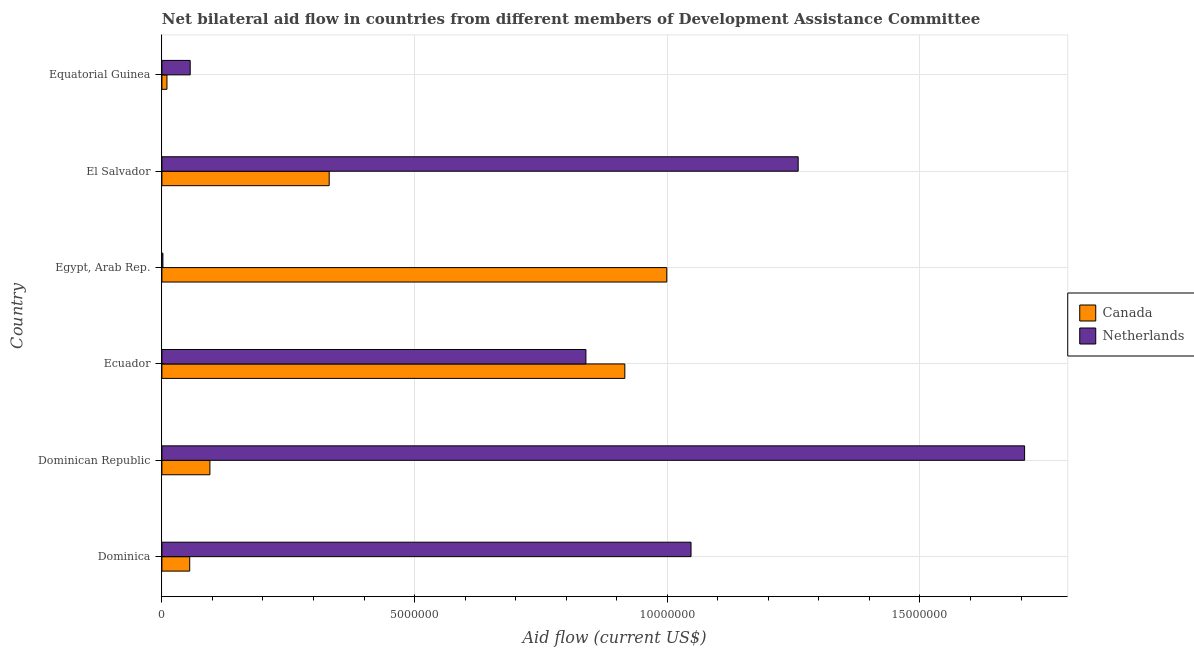How many different coloured bars are there?
Offer a very short reply. 2. Are the number of bars per tick equal to the number of legend labels?
Make the answer very short. Yes. Are the number of bars on each tick of the Y-axis equal?
Make the answer very short. Yes. How many bars are there on the 4th tick from the top?
Make the answer very short. 2. What is the label of the 3rd group of bars from the top?
Your answer should be compact. Egypt, Arab Rep. In how many cases, is the number of bars for a given country not equal to the number of legend labels?
Offer a very short reply. 0. What is the amount of aid given by netherlands in Ecuador?
Provide a succinct answer. 8.39e+06. Across all countries, what is the maximum amount of aid given by netherlands?
Ensure brevity in your answer.  1.71e+07. Across all countries, what is the minimum amount of aid given by netherlands?
Offer a very short reply. 2.00e+04. In which country was the amount of aid given by netherlands maximum?
Your answer should be very brief. Dominican Republic. In which country was the amount of aid given by netherlands minimum?
Your answer should be compact. Egypt, Arab Rep. What is the total amount of aid given by canada in the graph?
Provide a succinct answer. 2.41e+07. What is the difference between the amount of aid given by canada in Dominican Republic and that in Equatorial Guinea?
Offer a terse response. 8.50e+05. What is the difference between the amount of aid given by canada in Ecuador and the amount of aid given by netherlands in Dominica?
Your answer should be compact. -1.31e+06. What is the average amount of aid given by netherlands per country?
Your answer should be compact. 8.18e+06. What is the difference between the amount of aid given by canada and amount of aid given by netherlands in Equatorial Guinea?
Your answer should be compact. -4.60e+05. What is the ratio of the amount of aid given by netherlands in Ecuador to that in El Salvador?
Your answer should be very brief. 0.67. Is the difference between the amount of aid given by canada in Egypt, Arab Rep. and El Salvador greater than the difference between the amount of aid given by netherlands in Egypt, Arab Rep. and El Salvador?
Your answer should be very brief. Yes. What is the difference between the highest and the second highest amount of aid given by canada?
Your response must be concise. 8.30e+05. What is the difference between the highest and the lowest amount of aid given by canada?
Provide a succinct answer. 9.89e+06. In how many countries, is the amount of aid given by netherlands greater than the average amount of aid given by netherlands taken over all countries?
Your answer should be compact. 4. How many countries are there in the graph?
Provide a succinct answer. 6. Does the graph contain any zero values?
Your answer should be very brief. No. Does the graph contain grids?
Provide a succinct answer. Yes. Where does the legend appear in the graph?
Provide a short and direct response. Center right. What is the title of the graph?
Ensure brevity in your answer.  Net bilateral aid flow in countries from different members of Development Assistance Committee. Does "RDB concessional" appear as one of the legend labels in the graph?
Ensure brevity in your answer.  No. What is the Aid flow (current US$) in Netherlands in Dominica?
Ensure brevity in your answer.  1.05e+07. What is the Aid flow (current US$) in Canada in Dominican Republic?
Give a very brief answer. 9.50e+05. What is the Aid flow (current US$) in Netherlands in Dominican Republic?
Your response must be concise. 1.71e+07. What is the Aid flow (current US$) of Canada in Ecuador?
Your response must be concise. 9.16e+06. What is the Aid flow (current US$) of Netherlands in Ecuador?
Give a very brief answer. 8.39e+06. What is the Aid flow (current US$) in Canada in Egypt, Arab Rep.?
Your answer should be very brief. 9.99e+06. What is the Aid flow (current US$) in Canada in El Salvador?
Offer a very short reply. 3.31e+06. What is the Aid flow (current US$) in Netherlands in El Salvador?
Give a very brief answer. 1.26e+07. What is the Aid flow (current US$) of Canada in Equatorial Guinea?
Make the answer very short. 1.00e+05. What is the Aid flow (current US$) of Netherlands in Equatorial Guinea?
Provide a short and direct response. 5.60e+05. Across all countries, what is the maximum Aid flow (current US$) of Canada?
Keep it short and to the point. 9.99e+06. Across all countries, what is the maximum Aid flow (current US$) of Netherlands?
Provide a succinct answer. 1.71e+07. Across all countries, what is the minimum Aid flow (current US$) in Canada?
Make the answer very short. 1.00e+05. What is the total Aid flow (current US$) of Canada in the graph?
Keep it short and to the point. 2.41e+07. What is the total Aid flow (current US$) in Netherlands in the graph?
Offer a very short reply. 4.91e+07. What is the difference between the Aid flow (current US$) of Canada in Dominica and that in Dominican Republic?
Ensure brevity in your answer.  -4.00e+05. What is the difference between the Aid flow (current US$) of Netherlands in Dominica and that in Dominican Republic?
Your response must be concise. -6.60e+06. What is the difference between the Aid flow (current US$) of Canada in Dominica and that in Ecuador?
Offer a terse response. -8.61e+06. What is the difference between the Aid flow (current US$) of Netherlands in Dominica and that in Ecuador?
Your answer should be very brief. 2.08e+06. What is the difference between the Aid flow (current US$) of Canada in Dominica and that in Egypt, Arab Rep.?
Make the answer very short. -9.44e+06. What is the difference between the Aid flow (current US$) of Netherlands in Dominica and that in Egypt, Arab Rep.?
Offer a very short reply. 1.04e+07. What is the difference between the Aid flow (current US$) of Canada in Dominica and that in El Salvador?
Provide a succinct answer. -2.76e+06. What is the difference between the Aid flow (current US$) of Netherlands in Dominica and that in El Salvador?
Provide a succinct answer. -2.12e+06. What is the difference between the Aid flow (current US$) in Netherlands in Dominica and that in Equatorial Guinea?
Ensure brevity in your answer.  9.91e+06. What is the difference between the Aid flow (current US$) in Canada in Dominican Republic and that in Ecuador?
Provide a short and direct response. -8.21e+06. What is the difference between the Aid flow (current US$) of Netherlands in Dominican Republic and that in Ecuador?
Your response must be concise. 8.68e+06. What is the difference between the Aid flow (current US$) of Canada in Dominican Republic and that in Egypt, Arab Rep.?
Your response must be concise. -9.04e+06. What is the difference between the Aid flow (current US$) in Netherlands in Dominican Republic and that in Egypt, Arab Rep.?
Your answer should be very brief. 1.70e+07. What is the difference between the Aid flow (current US$) in Canada in Dominican Republic and that in El Salvador?
Provide a succinct answer. -2.36e+06. What is the difference between the Aid flow (current US$) of Netherlands in Dominican Republic and that in El Salvador?
Offer a very short reply. 4.48e+06. What is the difference between the Aid flow (current US$) of Canada in Dominican Republic and that in Equatorial Guinea?
Ensure brevity in your answer.  8.50e+05. What is the difference between the Aid flow (current US$) of Netherlands in Dominican Republic and that in Equatorial Guinea?
Keep it short and to the point. 1.65e+07. What is the difference between the Aid flow (current US$) in Canada in Ecuador and that in Egypt, Arab Rep.?
Your response must be concise. -8.30e+05. What is the difference between the Aid flow (current US$) of Netherlands in Ecuador and that in Egypt, Arab Rep.?
Keep it short and to the point. 8.37e+06. What is the difference between the Aid flow (current US$) of Canada in Ecuador and that in El Salvador?
Ensure brevity in your answer.  5.85e+06. What is the difference between the Aid flow (current US$) of Netherlands in Ecuador and that in El Salvador?
Ensure brevity in your answer.  -4.20e+06. What is the difference between the Aid flow (current US$) of Canada in Ecuador and that in Equatorial Guinea?
Your response must be concise. 9.06e+06. What is the difference between the Aid flow (current US$) of Netherlands in Ecuador and that in Equatorial Guinea?
Keep it short and to the point. 7.83e+06. What is the difference between the Aid flow (current US$) in Canada in Egypt, Arab Rep. and that in El Salvador?
Your answer should be very brief. 6.68e+06. What is the difference between the Aid flow (current US$) in Netherlands in Egypt, Arab Rep. and that in El Salvador?
Offer a very short reply. -1.26e+07. What is the difference between the Aid flow (current US$) of Canada in Egypt, Arab Rep. and that in Equatorial Guinea?
Your response must be concise. 9.89e+06. What is the difference between the Aid flow (current US$) of Netherlands in Egypt, Arab Rep. and that in Equatorial Guinea?
Your answer should be very brief. -5.40e+05. What is the difference between the Aid flow (current US$) in Canada in El Salvador and that in Equatorial Guinea?
Make the answer very short. 3.21e+06. What is the difference between the Aid flow (current US$) of Netherlands in El Salvador and that in Equatorial Guinea?
Make the answer very short. 1.20e+07. What is the difference between the Aid flow (current US$) in Canada in Dominica and the Aid flow (current US$) in Netherlands in Dominican Republic?
Provide a succinct answer. -1.65e+07. What is the difference between the Aid flow (current US$) of Canada in Dominica and the Aid flow (current US$) of Netherlands in Ecuador?
Provide a short and direct response. -7.84e+06. What is the difference between the Aid flow (current US$) in Canada in Dominica and the Aid flow (current US$) in Netherlands in Egypt, Arab Rep.?
Ensure brevity in your answer.  5.30e+05. What is the difference between the Aid flow (current US$) of Canada in Dominica and the Aid flow (current US$) of Netherlands in El Salvador?
Offer a terse response. -1.20e+07. What is the difference between the Aid flow (current US$) of Canada in Dominica and the Aid flow (current US$) of Netherlands in Equatorial Guinea?
Ensure brevity in your answer.  -10000. What is the difference between the Aid flow (current US$) of Canada in Dominican Republic and the Aid flow (current US$) of Netherlands in Ecuador?
Give a very brief answer. -7.44e+06. What is the difference between the Aid flow (current US$) of Canada in Dominican Republic and the Aid flow (current US$) of Netherlands in Egypt, Arab Rep.?
Give a very brief answer. 9.30e+05. What is the difference between the Aid flow (current US$) of Canada in Dominican Republic and the Aid flow (current US$) of Netherlands in El Salvador?
Your answer should be very brief. -1.16e+07. What is the difference between the Aid flow (current US$) of Canada in Ecuador and the Aid flow (current US$) of Netherlands in Egypt, Arab Rep.?
Your answer should be compact. 9.14e+06. What is the difference between the Aid flow (current US$) of Canada in Ecuador and the Aid flow (current US$) of Netherlands in El Salvador?
Your answer should be compact. -3.43e+06. What is the difference between the Aid flow (current US$) in Canada in Ecuador and the Aid flow (current US$) in Netherlands in Equatorial Guinea?
Offer a very short reply. 8.60e+06. What is the difference between the Aid flow (current US$) in Canada in Egypt, Arab Rep. and the Aid flow (current US$) in Netherlands in El Salvador?
Ensure brevity in your answer.  -2.60e+06. What is the difference between the Aid flow (current US$) of Canada in Egypt, Arab Rep. and the Aid flow (current US$) of Netherlands in Equatorial Guinea?
Your answer should be very brief. 9.43e+06. What is the difference between the Aid flow (current US$) of Canada in El Salvador and the Aid flow (current US$) of Netherlands in Equatorial Guinea?
Provide a short and direct response. 2.75e+06. What is the average Aid flow (current US$) in Canada per country?
Make the answer very short. 4.01e+06. What is the average Aid flow (current US$) of Netherlands per country?
Ensure brevity in your answer.  8.18e+06. What is the difference between the Aid flow (current US$) in Canada and Aid flow (current US$) in Netherlands in Dominica?
Offer a terse response. -9.92e+06. What is the difference between the Aid flow (current US$) of Canada and Aid flow (current US$) of Netherlands in Dominican Republic?
Provide a short and direct response. -1.61e+07. What is the difference between the Aid flow (current US$) of Canada and Aid flow (current US$) of Netherlands in Ecuador?
Your response must be concise. 7.70e+05. What is the difference between the Aid flow (current US$) in Canada and Aid flow (current US$) in Netherlands in Egypt, Arab Rep.?
Give a very brief answer. 9.97e+06. What is the difference between the Aid flow (current US$) of Canada and Aid flow (current US$) of Netherlands in El Salvador?
Keep it short and to the point. -9.28e+06. What is the difference between the Aid flow (current US$) of Canada and Aid flow (current US$) of Netherlands in Equatorial Guinea?
Provide a short and direct response. -4.60e+05. What is the ratio of the Aid flow (current US$) in Canada in Dominica to that in Dominican Republic?
Offer a very short reply. 0.58. What is the ratio of the Aid flow (current US$) of Netherlands in Dominica to that in Dominican Republic?
Ensure brevity in your answer.  0.61. What is the ratio of the Aid flow (current US$) in Canada in Dominica to that in Ecuador?
Your response must be concise. 0.06. What is the ratio of the Aid flow (current US$) in Netherlands in Dominica to that in Ecuador?
Offer a very short reply. 1.25. What is the ratio of the Aid flow (current US$) in Canada in Dominica to that in Egypt, Arab Rep.?
Provide a succinct answer. 0.06. What is the ratio of the Aid flow (current US$) in Netherlands in Dominica to that in Egypt, Arab Rep.?
Your answer should be compact. 523.5. What is the ratio of the Aid flow (current US$) of Canada in Dominica to that in El Salvador?
Your answer should be compact. 0.17. What is the ratio of the Aid flow (current US$) of Netherlands in Dominica to that in El Salvador?
Provide a short and direct response. 0.83. What is the ratio of the Aid flow (current US$) of Netherlands in Dominica to that in Equatorial Guinea?
Your answer should be compact. 18.7. What is the ratio of the Aid flow (current US$) of Canada in Dominican Republic to that in Ecuador?
Your answer should be compact. 0.1. What is the ratio of the Aid flow (current US$) in Netherlands in Dominican Republic to that in Ecuador?
Provide a short and direct response. 2.03. What is the ratio of the Aid flow (current US$) of Canada in Dominican Republic to that in Egypt, Arab Rep.?
Give a very brief answer. 0.1. What is the ratio of the Aid flow (current US$) of Netherlands in Dominican Republic to that in Egypt, Arab Rep.?
Make the answer very short. 853.5. What is the ratio of the Aid flow (current US$) in Canada in Dominican Republic to that in El Salvador?
Your response must be concise. 0.29. What is the ratio of the Aid flow (current US$) in Netherlands in Dominican Republic to that in El Salvador?
Your answer should be compact. 1.36. What is the ratio of the Aid flow (current US$) in Canada in Dominican Republic to that in Equatorial Guinea?
Make the answer very short. 9.5. What is the ratio of the Aid flow (current US$) of Netherlands in Dominican Republic to that in Equatorial Guinea?
Your answer should be very brief. 30.48. What is the ratio of the Aid flow (current US$) of Canada in Ecuador to that in Egypt, Arab Rep.?
Ensure brevity in your answer.  0.92. What is the ratio of the Aid flow (current US$) in Netherlands in Ecuador to that in Egypt, Arab Rep.?
Give a very brief answer. 419.5. What is the ratio of the Aid flow (current US$) in Canada in Ecuador to that in El Salvador?
Your answer should be compact. 2.77. What is the ratio of the Aid flow (current US$) of Netherlands in Ecuador to that in El Salvador?
Offer a terse response. 0.67. What is the ratio of the Aid flow (current US$) in Canada in Ecuador to that in Equatorial Guinea?
Offer a very short reply. 91.6. What is the ratio of the Aid flow (current US$) in Netherlands in Ecuador to that in Equatorial Guinea?
Your answer should be very brief. 14.98. What is the ratio of the Aid flow (current US$) of Canada in Egypt, Arab Rep. to that in El Salvador?
Give a very brief answer. 3.02. What is the ratio of the Aid flow (current US$) of Netherlands in Egypt, Arab Rep. to that in El Salvador?
Your answer should be very brief. 0. What is the ratio of the Aid flow (current US$) in Canada in Egypt, Arab Rep. to that in Equatorial Guinea?
Make the answer very short. 99.9. What is the ratio of the Aid flow (current US$) of Netherlands in Egypt, Arab Rep. to that in Equatorial Guinea?
Offer a terse response. 0.04. What is the ratio of the Aid flow (current US$) of Canada in El Salvador to that in Equatorial Guinea?
Ensure brevity in your answer.  33.1. What is the ratio of the Aid flow (current US$) of Netherlands in El Salvador to that in Equatorial Guinea?
Your response must be concise. 22.48. What is the difference between the highest and the second highest Aid flow (current US$) of Canada?
Offer a very short reply. 8.30e+05. What is the difference between the highest and the second highest Aid flow (current US$) of Netherlands?
Give a very brief answer. 4.48e+06. What is the difference between the highest and the lowest Aid flow (current US$) in Canada?
Keep it short and to the point. 9.89e+06. What is the difference between the highest and the lowest Aid flow (current US$) in Netherlands?
Give a very brief answer. 1.70e+07. 